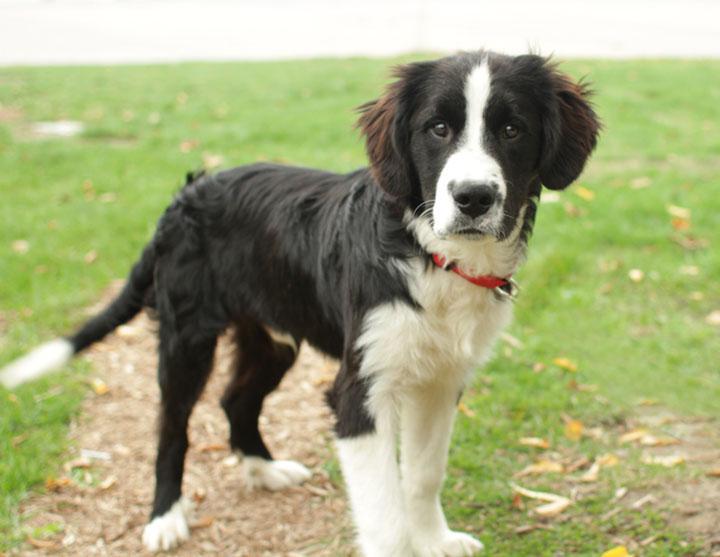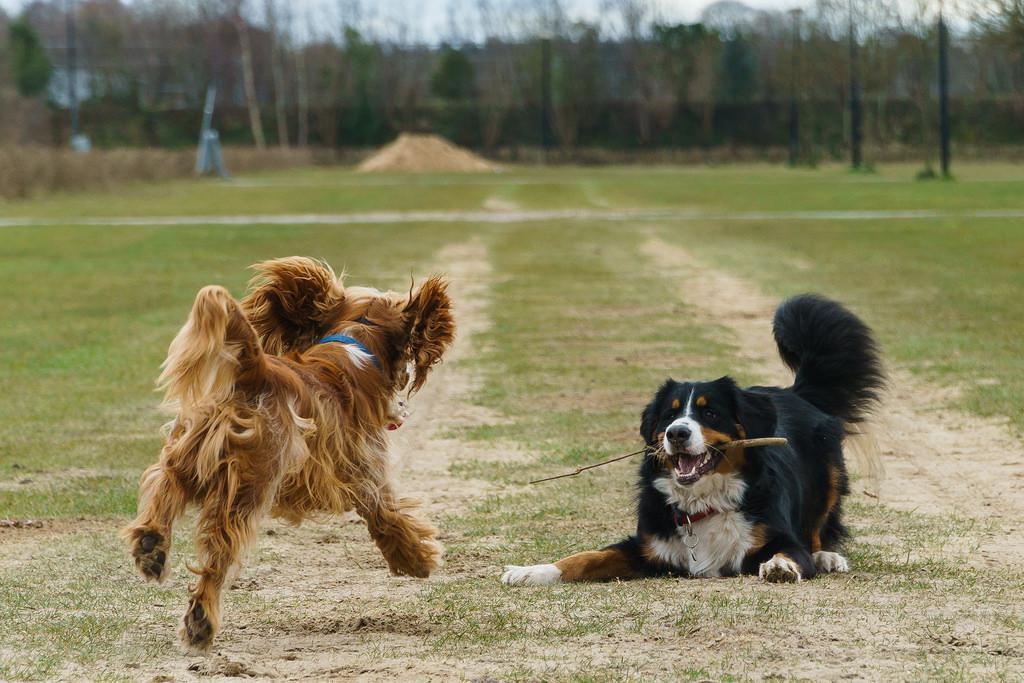The first image is the image on the left, the second image is the image on the right. Evaluate the accuracy of this statement regarding the images: "The left image contains a single standing dog, and the right image shows two dogs interacting outdoors.". Is it true? Answer yes or no. Yes. The first image is the image on the left, the second image is the image on the right. Examine the images to the left and right. Is the description "In one of the images there are 2 dogs playing on the grass." accurate? Answer yes or no. Yes. 